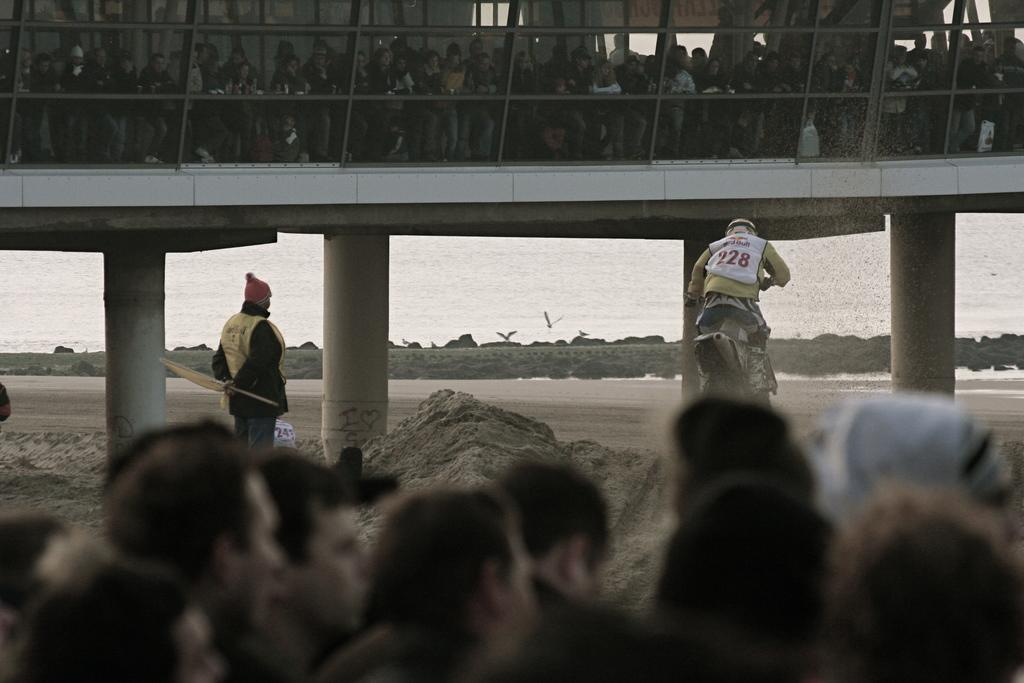How many people are in the image? There is a group of people in the image, but the exact number cannot be determined from the provided facts. What structure can be seen in the image? There is a bridge in the image. What natural element is visible in the background of the image? Water is visible in the background of the image. What type of floor can be seen under the bridge in the image? There is no floor visible under the bridge in the image; it appears to be suspended over the water. What kind of flame is present near the group of people in the image? There is no flame present near the group of people in the image. 